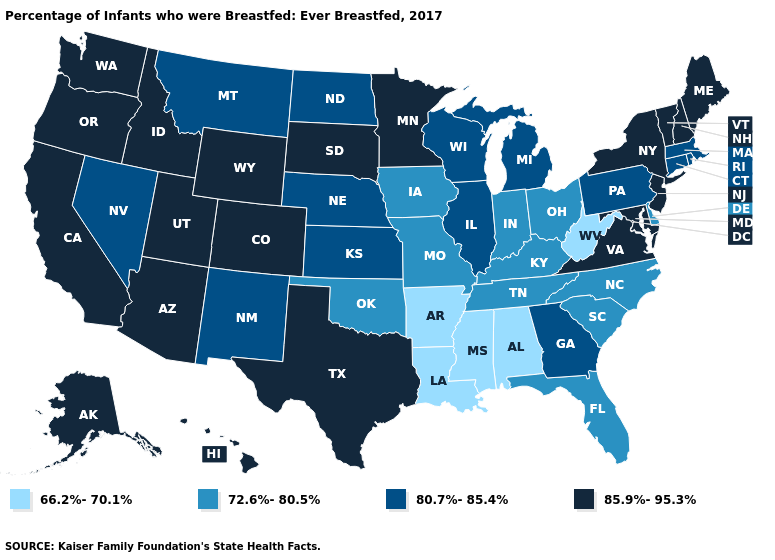What is the highest value in the Northeast ?
Short answer required. 85.9%-95.3%. What is the value of Oregon?
Give a very brief answer. 85.9%-95.3%. Does the map have missing data?
Write a very short answer. No. Among the states that border Alabama , does Georgia have the highest value?
Short answer required. Yes. Name the states that have a value in the range 72.6%-80.5%?
Short answer required. Delaware, Florida, Indiana, Iowa, Kentucky, Missouri, North Carolina, Ohio, Oklahoma, South Carolina, Tennessee. What is the lowest value in the USA?
Concise answer only. 66.2%-70.1%. Which states have the highest value in the USA?
Short answer required. Alaska, Arizona, California, Colorado, Hawaii, Idaho, Maine, Maryland, Minnesota, New Hampshire, New Jersey, New York, Oregon, South Dakota, Texas, Utah, Vermont, Virginia, Washington, Wyoming. Which states have the lowest value in the USA?
Concise answer only. Alabama, Arkansas, Louisiana, Mississippi, West Virginia. Does the first symbol in the legend represent the smallest category?
Concise answer only. Yes. Does Minnesota have the highest value in the MidWest?
Be succinct. Yes. Does Minnesota have the highest value in the MidWest?
Be succinct. Yes. Does South Carolina have the highest value in the USA?
Be succinct. No. Does Oregon have the lowest value in the West?
Answer briefly. No. What is the value of Colorado?
Be succinct. 85.9%-95.3%. What is the lowest value in states that border California?
Quick response, please. 80.7%-85.4%. 